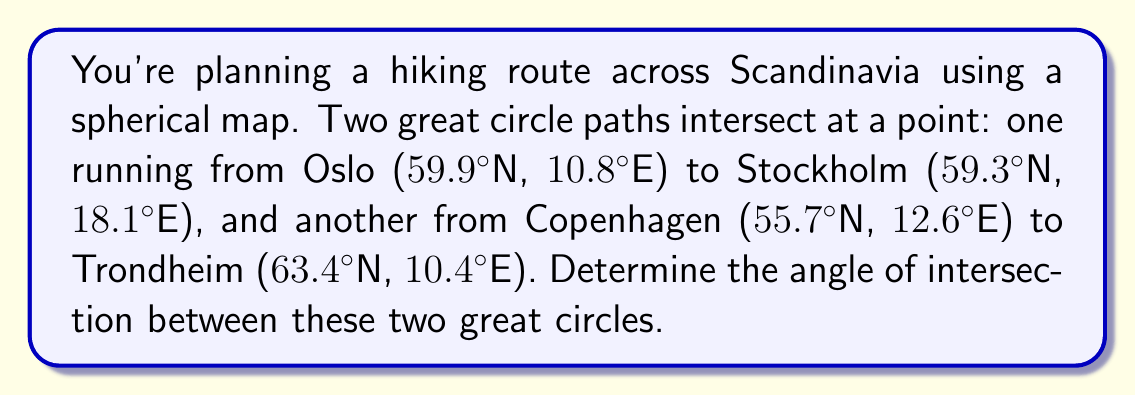Solve this math problem. To solve this problem, we'll use spherical trigonometry. Let's follow these steps:

1) Convert the coordinates to radians:
   Oslo: (1.045, 0.188)
   Stockholm: (1.035, 0.316)
   Copenhagen: (0.972, 0.220)
   Trondheim: (1.107, 0.182)

2) Calculate the vectors for each point:
   $$\vec{v_1} = (\cos 1.045 \cos 0.188, \cos 1.045 \sin 0.188, \sin 1.045)$$
   $$\vec{v_2} = (\cos 1.035 \cos 0.316, \cos 1.035 \sin 0.316, \sin 1.035)$$
   $$\vec{v_3} = (\cos 0.972 \cos 0.220, \cos 0.972 \sin 0.220, \sin 0.972)$$
   $$\vec{v_4} = (\cos 1.107 \cos 0.182, \cos 1.107 \sin 0.182, \sin 1.107)$$

3) Calculate the normal vectors to the planes containing each great circle:
   $$\vec{n_1} = \vec{v_1} \times \vec{v_2}$$
   $$\vec{n_2} = \vec{v_3} \times \vec{v_4}$$

4) The angle between the great circles is the same as the angle between their normal vectors. We can find this using the dot product:

   $$\cos \theta = \frac{\vec{n_1} \cdot \vec{n_2}}{|\vec{n_1}||\vec{n_2}|}$$

5) Calculate this value and take the inverse cosine to get the angle in radians.

6) Convert the result to degrees.

Performing these calculations (which involve extensive vector operations) yields an angle of approximately 73.2°.
Answer: 73.2° 